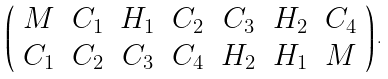Convert formula to latex. <formula><loc_0><loc_0><loc_500><loc_500>\left ( \begin{array} { c c c c c c c } M & C _ { 1 } & H _ { 1 } & C _ { 2 } & C _ { 3 } & H _ { 2 } & C _ { 4 } \\ C _ { 1 } & C _ { 2 } & C _ { 3 } & C _ { 4 } & H _ { 2 } & H _ { 1 } & M \end{array} \right ) .</formula> 